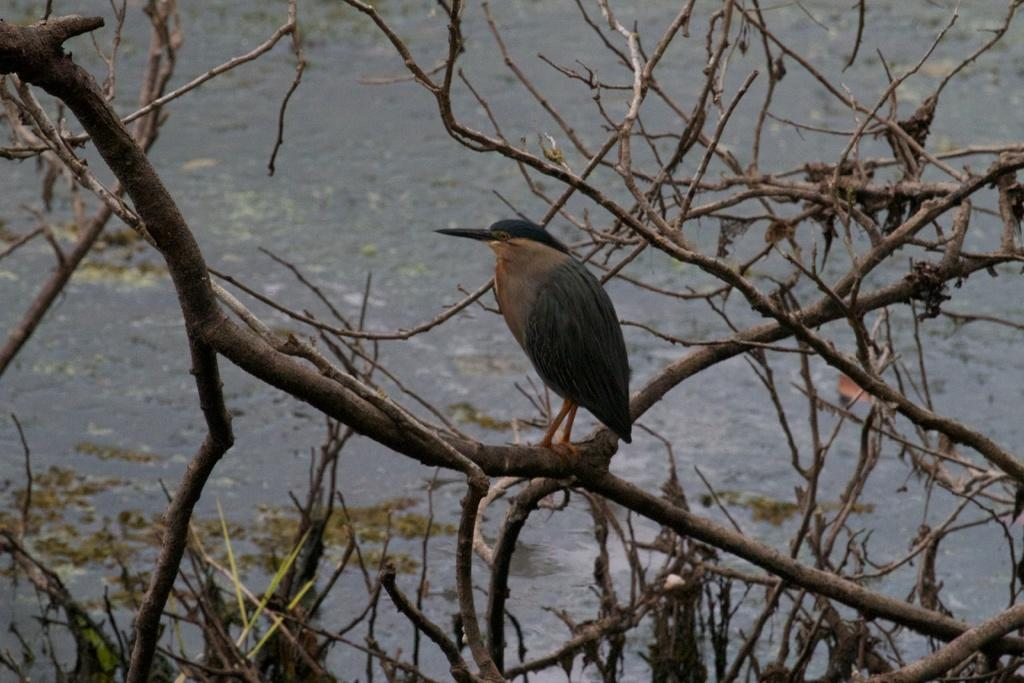What can be seen in the image that is related to nature? There are branches in the image. Is there any wildlife present on the branches? Yes, there is a bird on one of the branches. What can be seen in the background of the image? There is water visible in the background of the image. What type of sofa can be seen in the image? There is no sofa present in the image. Can you tell me how many people from the company are visible in the image? There is no reference to a company or any people in the image, so it's not possible to determine the number of people from the company. 